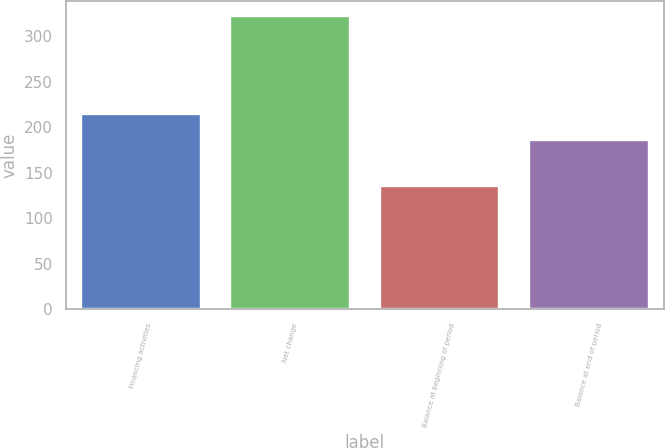Convert chart. <chart><loc_0><loc_0><loc_500><loc_500><bar_chart><fcel>Financing activities<fcel>Net change<fcel>Balance at beginning of period<fcel>Balance at end of period<nl><fcel>215<fcel>322<fcel>136<fcel>186<nl></chart> 